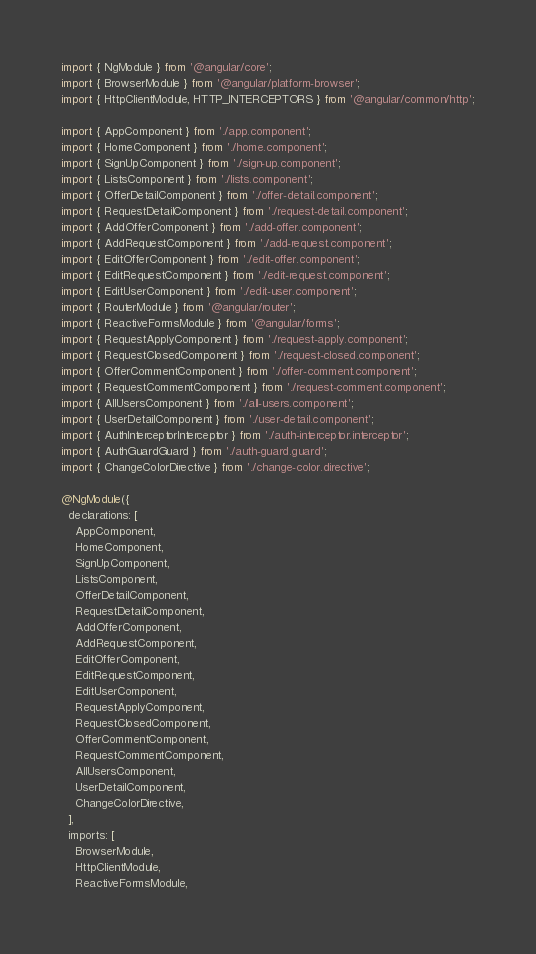Convert code to text. <code><loc_0><loc_0><loc_500><loc_500><_TypeScript_>import { NgModule } from '@angular/core';
import { BrowserModule } from '@angular/platform-browser';
import { HttpClientModule, HTTP_INTERCEPTORS } from '@angular/common/http';

import { AppComponent } from './app.component';
import { HomeComponent } from './home.component';
import { SignUpComponent } from './sign-up.component';
import { ListsComponent } from './lists.component';
import { OfferDetailComponent } from './offer-detail.component';
import { RequestDetailComponent } from './request-detail.component';
import { AddOfferComponent } from './add-offer.component';
import { AddRequestComponent } from './add-request.component';
import { EditOfferComponent } from './edit-offer.component';
import { EditRequestComponent } from './edit-request.component';
import { EditUserComponent } from './edit-user.component';
import { RouterModule } from '@angular/router';
import { ReactiveFormsModule } from '@angular/forms';
import { RequestApplyComponent } from './request-apply.component';
import { RequestClosedComponent } from './request-closed.component';
import { OfferCommentComponent } from './offer-comment.component';
import { RequestCommentComponent } from './request-comment.component';
import { AllUsersComponent } from './all-users.component';
import { UserDetailComponent } from './user-detail.component';
import { AuthInterceptorInterceptor } from './auth-interceptor.interceptor';
import { AuthGuardGuard } from './auth-guard.guard';
import { ChangeColorDirective } from './change-color.directive';

@NgModule({
  declarations: [
    AppComponent,
    HomeComponent,
    SignUpComponent,
    ListsComponent,
    OfferDetailComponent,
    RequestDetailComponent,
    AddOfferComponent,
    AddRequestComponent,
    EditOfferComponent,
    EditRequestComponent,
    EditUserComponent,
    RequestApplyComponent,
    RequestClosedComponent,
    OfferCommentComponent,
    RequestCommentComponent,
    AllUsersComponent,
    UserDetailComponent,
    ChangeColorDirective,
  ],
  imports: [
    BrowserModule,
    HttpClientModule,
    ReactiveFormsModule,</code> 